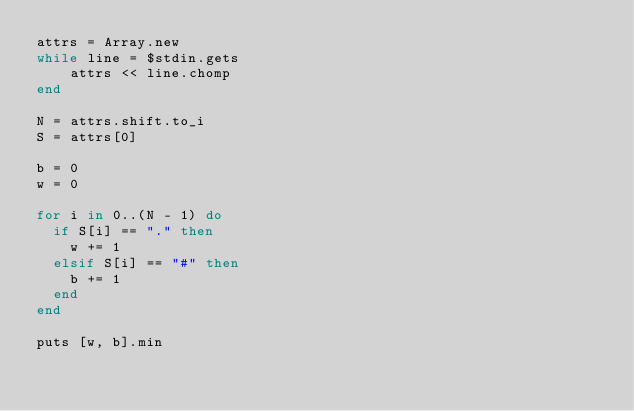<code> <loc_0><loc_0><loc_500><loc_500><_Ruby_>attrs = Array.new
while line = $stdin.gets
    attrs << line.chomp
end

N = attrs.shift.to_i
S = attrs[0]

b = 0
w = 0

for i in 0..(N - 1) do
  if S[i] == "." then
    w += 1
  elsif S[i] == "#" then
    b += 1
  end
end

puts [w, b].min</code> 